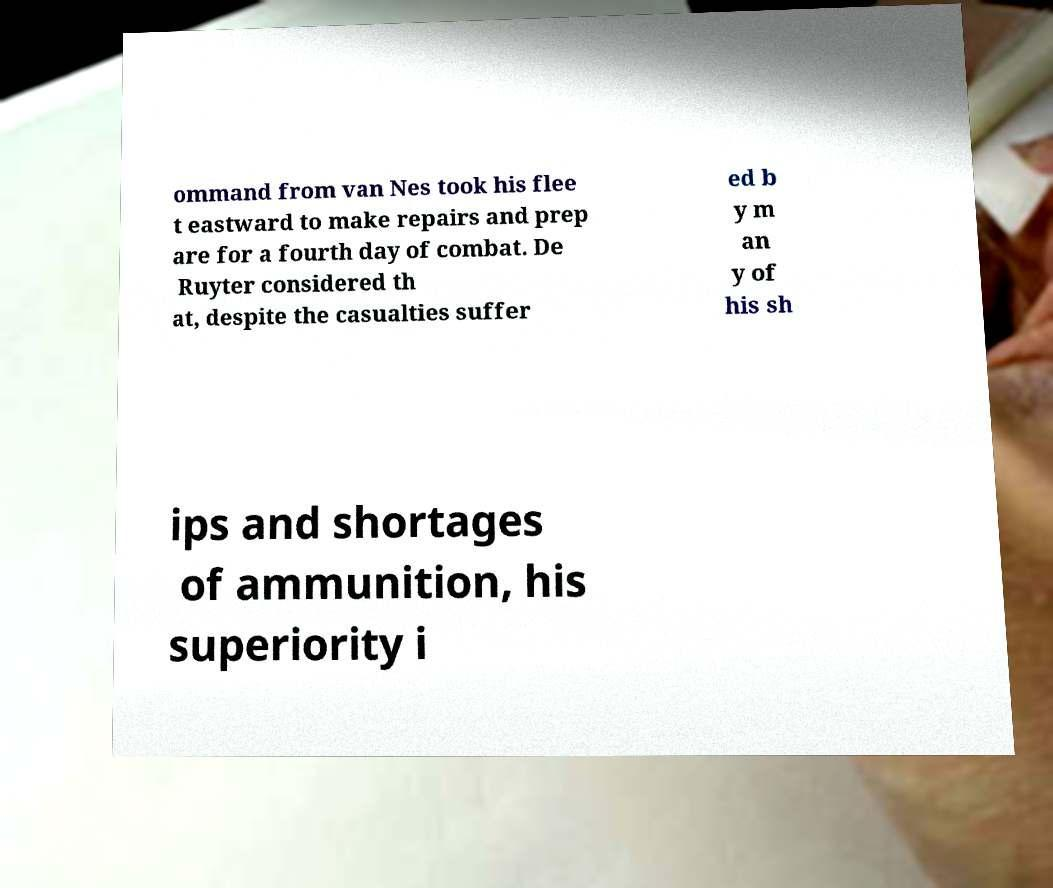Could you assist in decoding the text presented in this image and type it out clearly? ommand from van Nes took his flee t eastward to make repairs and prep are for a fourth day of combat. De Ruyter considered th at, despite the casualties suffer ed b y m an y of his sh ips and shortages of ammunition, his superiority i 